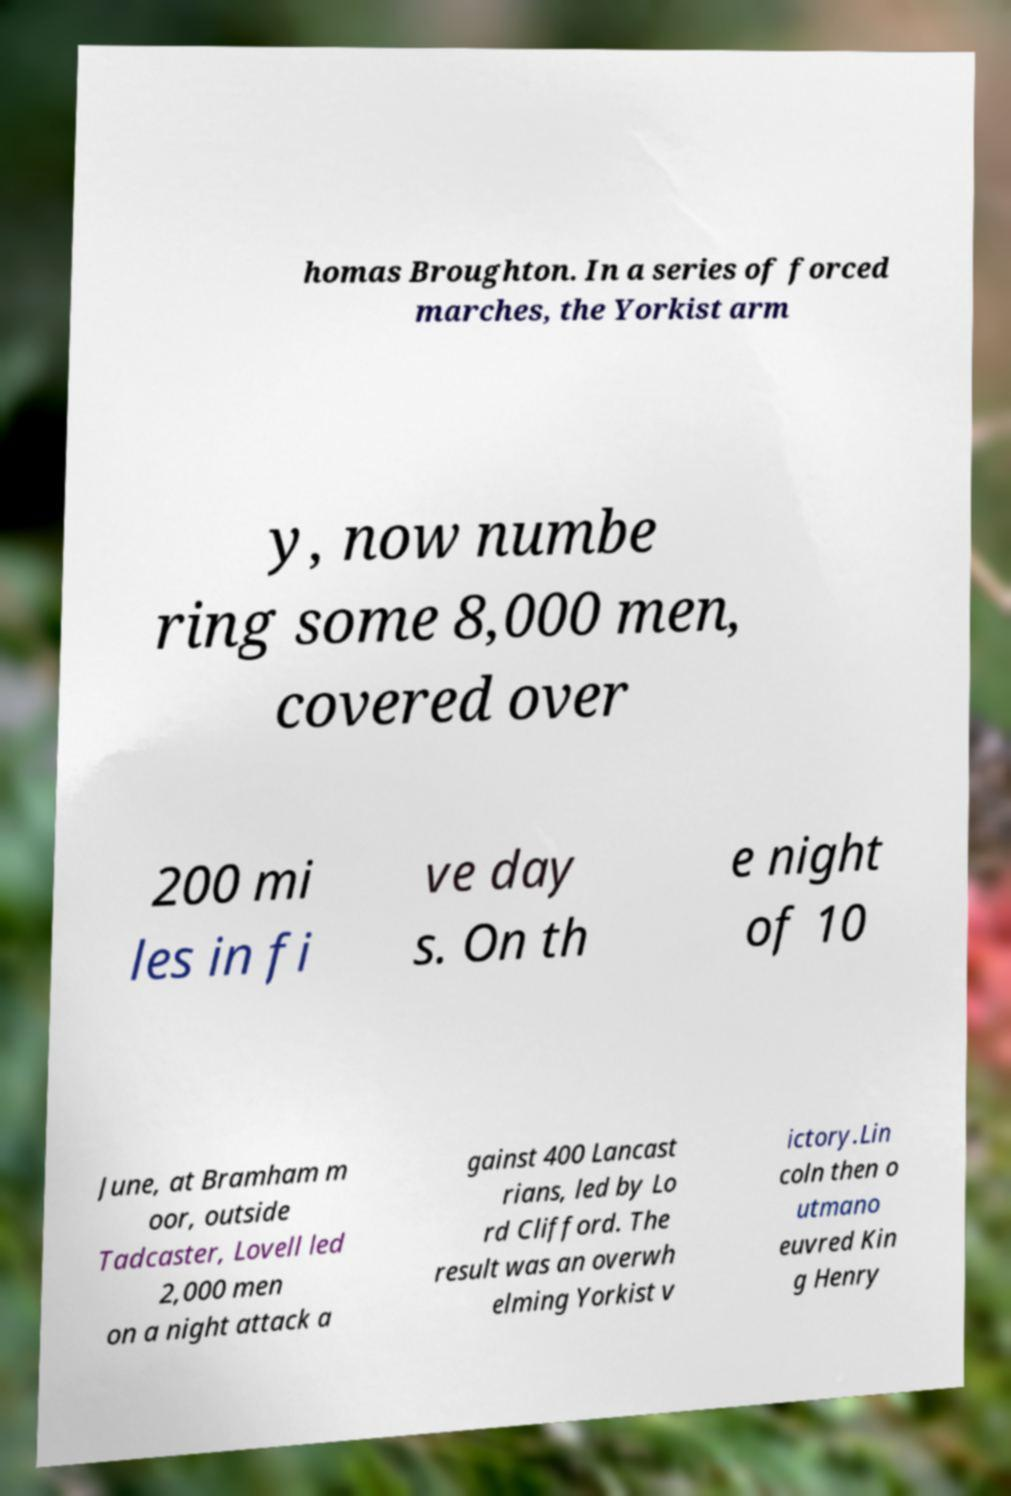For documentation purposes, I need the text within this image transcribed. Could you provide that? homas Broughton. In a series of forced marches, the Yorkist arm y, now numbe ring some 8,000 men, covered over 200 mi les in fi ve day s. On th e night of 10 June, at Bramham m oor, outside Tadcaster, Lovell led 2,000 men on a night attack a gainst 400 Lancast rians, led by Lo rd Clifford. The result was an overwh elming Yorkist v ictory.Lin coln then o utmano euvred Kin g Henry 